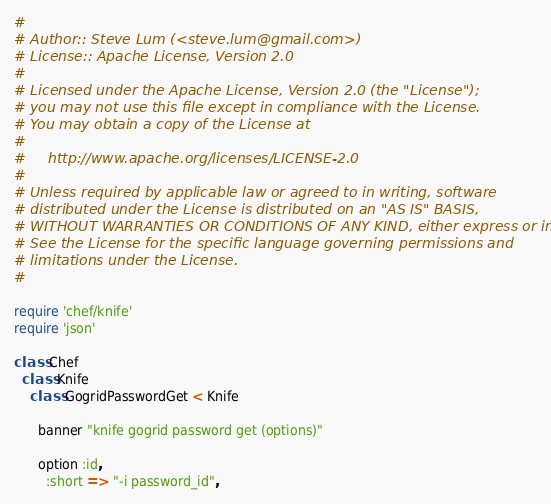Convert code to text. <code><loc_0><loc_0><loc_500><loc_500><_Ruby_>#
# Author:: Steve Lum (<steve.lum@gmail.com>)
# License:: Apache License, Version 2.0
#
# Licensed under the Apache License, Version 2.0 (the "License");
# you may not use this file except in compliance with the License.
# You may obtain a copy of the License at
# 
#     http://www.apache.org/licenses/LICENSE-2.0
# 
# Unless required by applicable law or agreed to in writing, software
# distributed under the License is distributed on an "AS IS" BASIS,
# WITHOUT WARRANTIES OR CONDITIONS OF ANY KIND, either express or implied.
# See the License for the specific language governing permissions and
# limitations under the License.
#

require 'chef/knife'
require 'json'

class Chef
  class Knife
    class GogridPasswordGet < Knife

      banner "knife gogrid password get (options)"

      option :id,
        :short => "-i password_id",</code> 